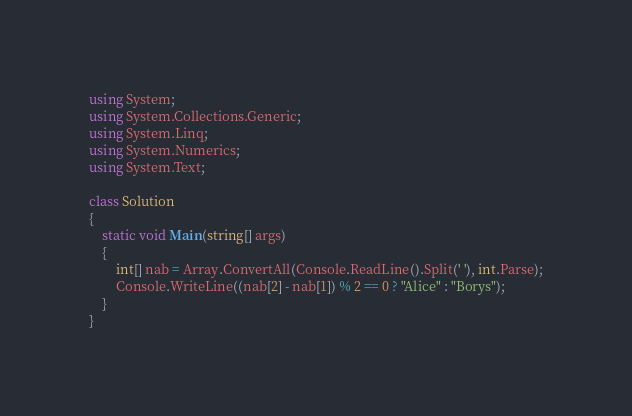Convert code to text. <code><loc_0><loc_0><loc_500><loc_500><_C#_>using System;
using System.Collections.Generic;
using System.Linq;
using System.Numerics;
using System.Text;

class Solution
{
    static void Main(string[] args)
    {
        int[] nab = Array.ConvertAll(Console.ReadLine().Split(' '), int.Parse);
        Console.WriteLine((nab[2] - nab[1]) % 2 == 0 ? "Alice" : "Borys");
    }
}
</code> 